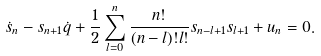Convert formula to latex. <formula><loc_0><loc_0><loc_500><loc_500>\dot { s } _ { n } - s _ { n + 1 } \dot { q } + \frac { 1 } { 2 } \sum _ { l = 0 } ^ { n } \frac { n ! } { ( n - l ) ! l ! } s _ { n - l + 1 } s _ { l + 1 } + u _ { n } = 0 .</formula> 